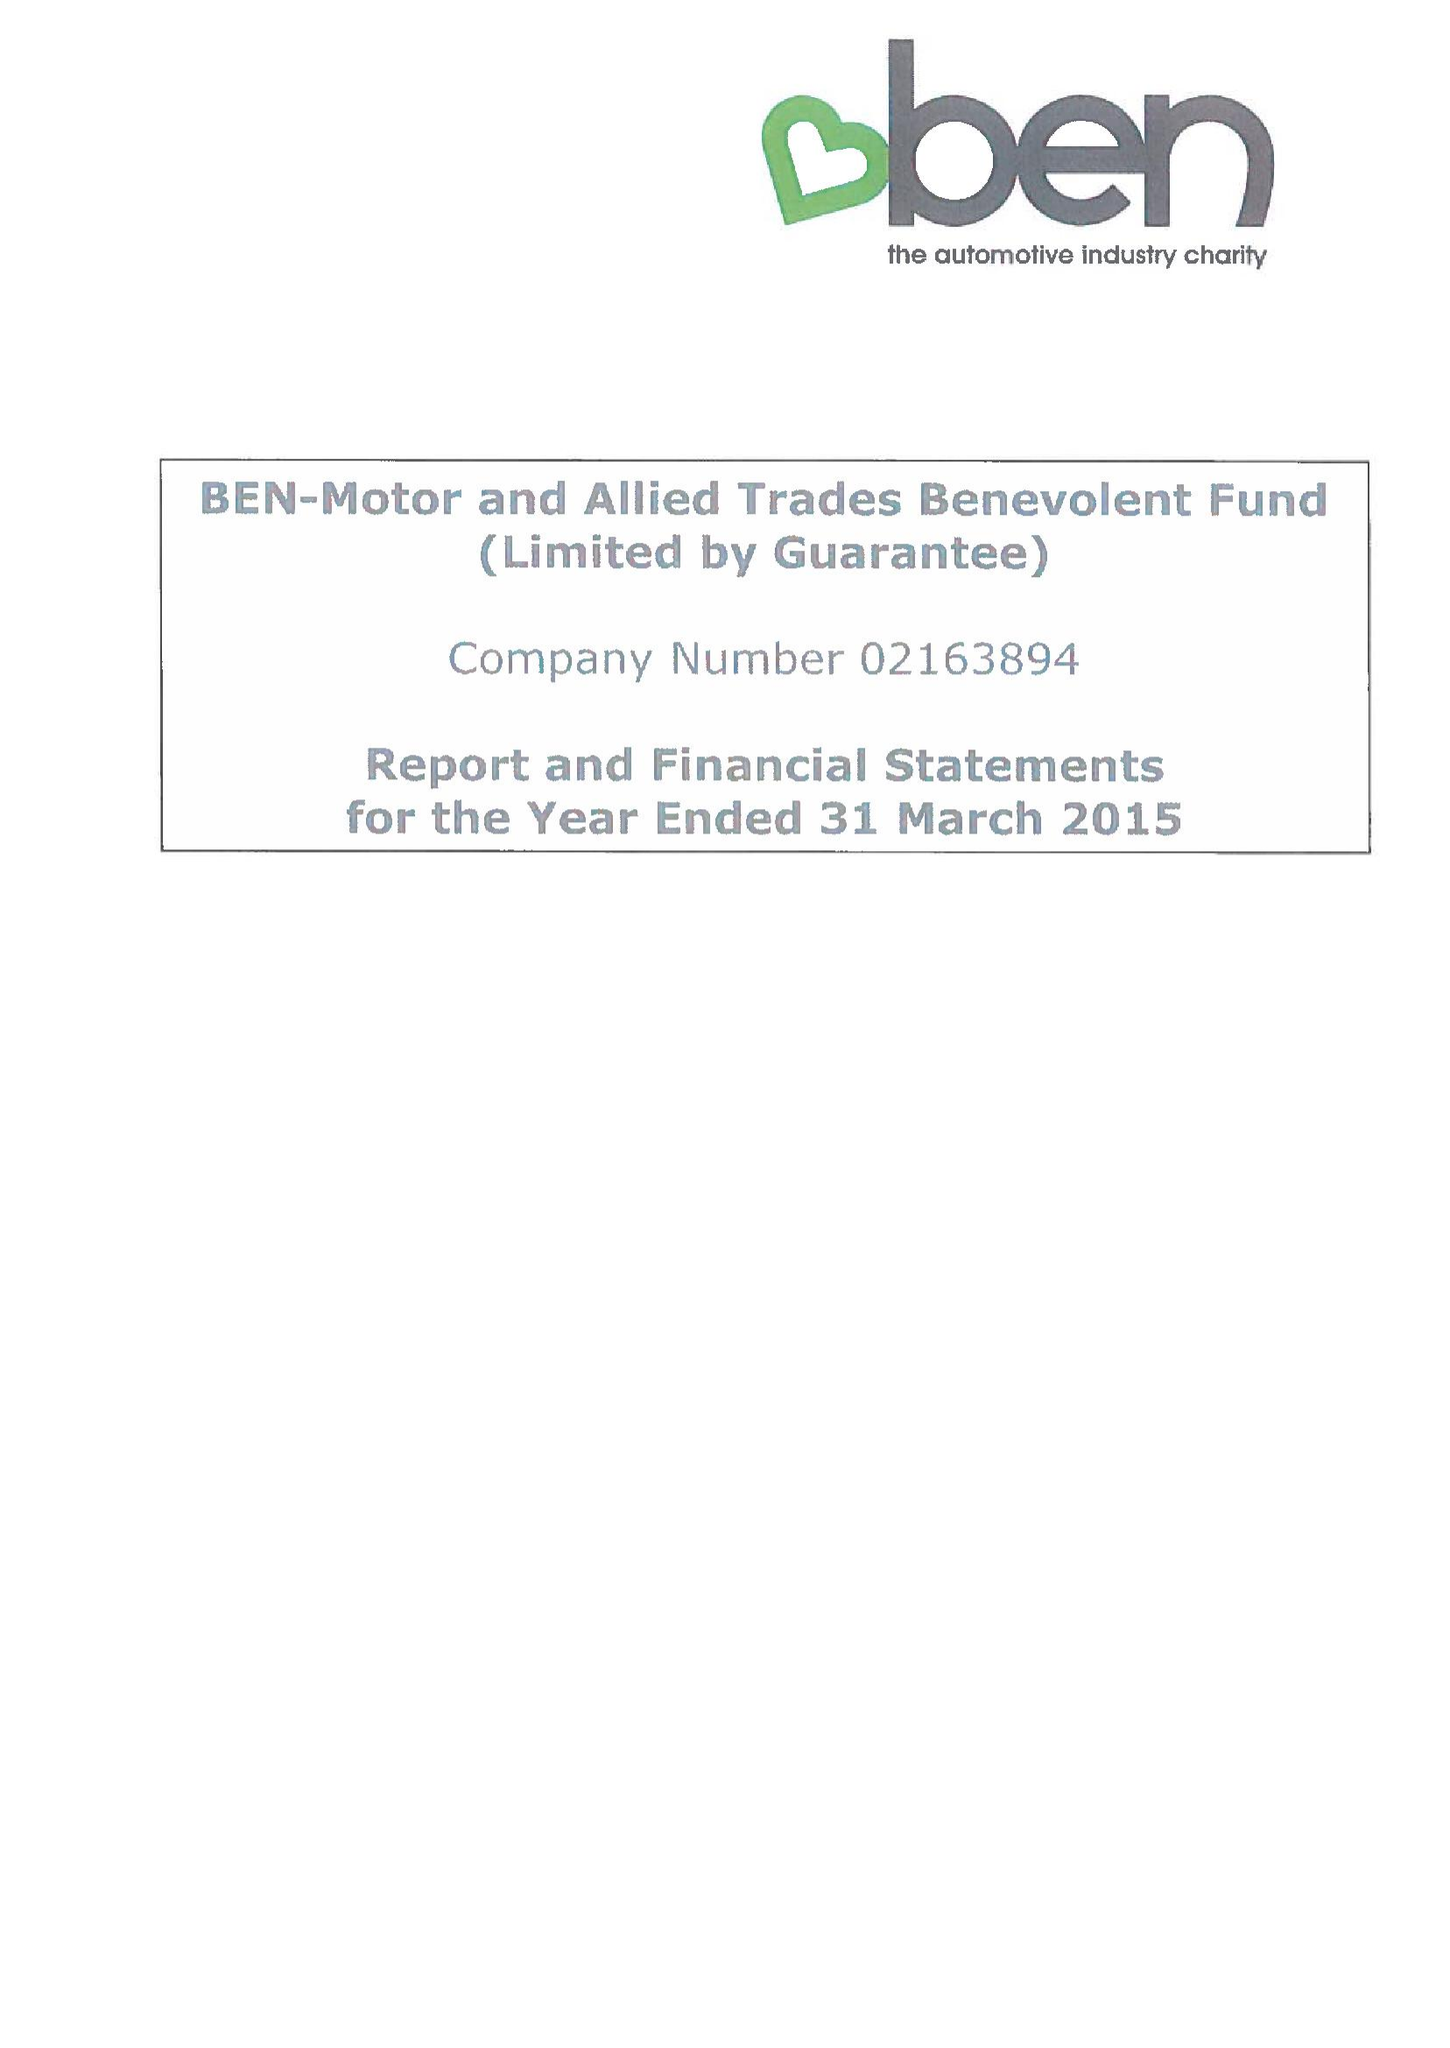What is the value for the address__postcode?
Answer the question using a single word or phrase. SL5 0FG 